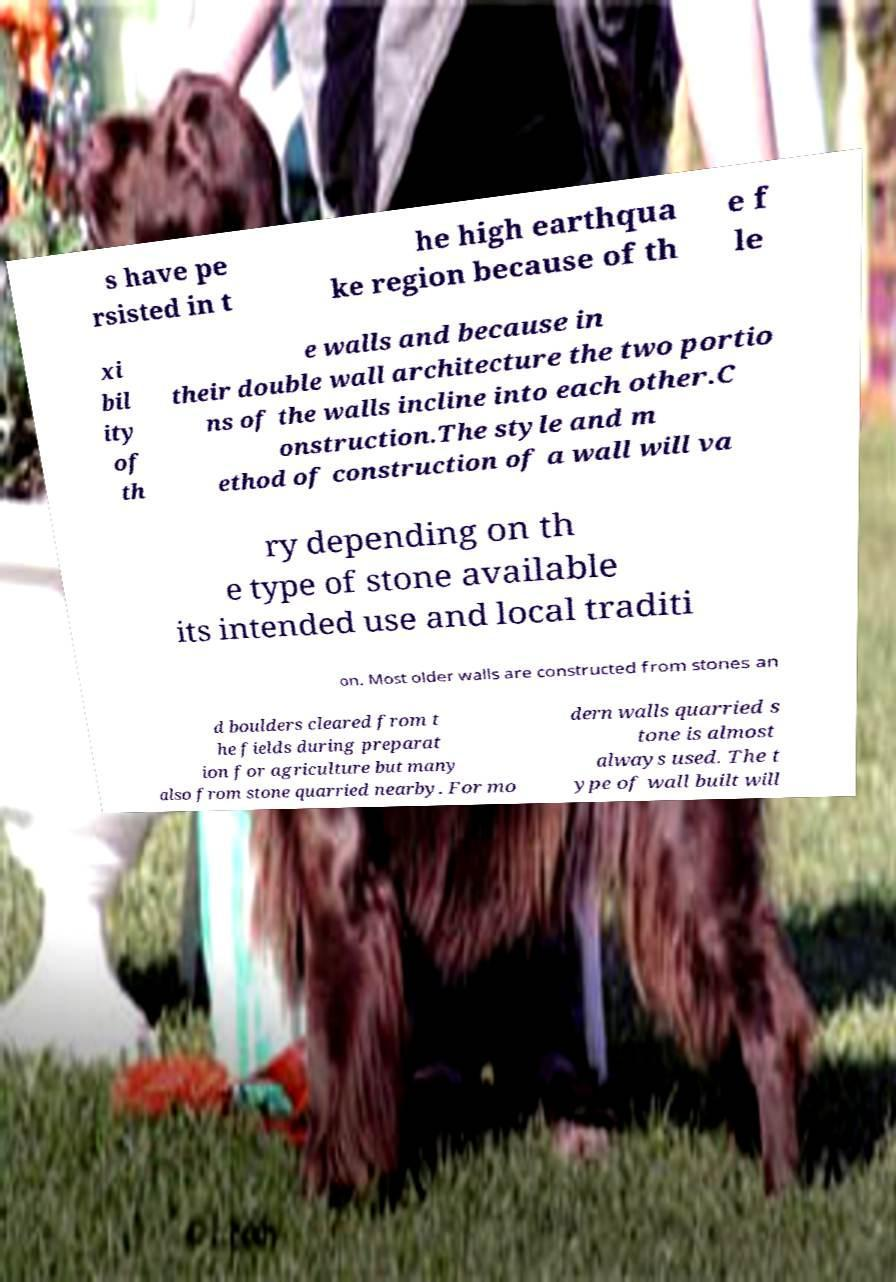Please identify and transcribe the text found in this image. s have pe rsisted in t he high earthqua ke region because of th e f le xi bil ity of th e walls and because in their double wall architecture the two portio ns of the walls incline into each other.C onstruction.The style and m ethod of construction of a wall will va ry depending on th e type of stone available its intended use and local traditi on. Most older walls are constructed from stones an d boulders cleared from t he fields during preparat ion for agriculture but many also from stone quarried nearby. For mo dern walls quarried s tone is almost always used. The t ype of wall built will 